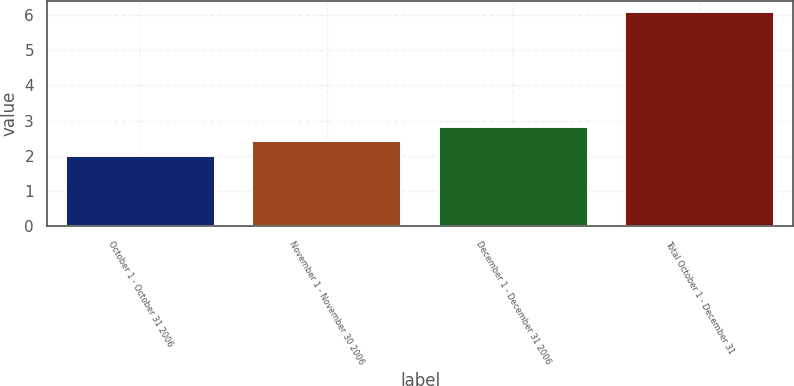Convert chart to OTSL. <chart><loc_0><loc_0><loc_500><loc_500><bar_chart><fcel>October 1 - October 31 2006<fcel>November 1 - November 30 2006<fcel>December 1 - December 31 2006<fcel>Total October 1 - December 31<nl><fcel>2<fcel>2.41<fcel>2.82<fcel>6.1<nl></chart> 